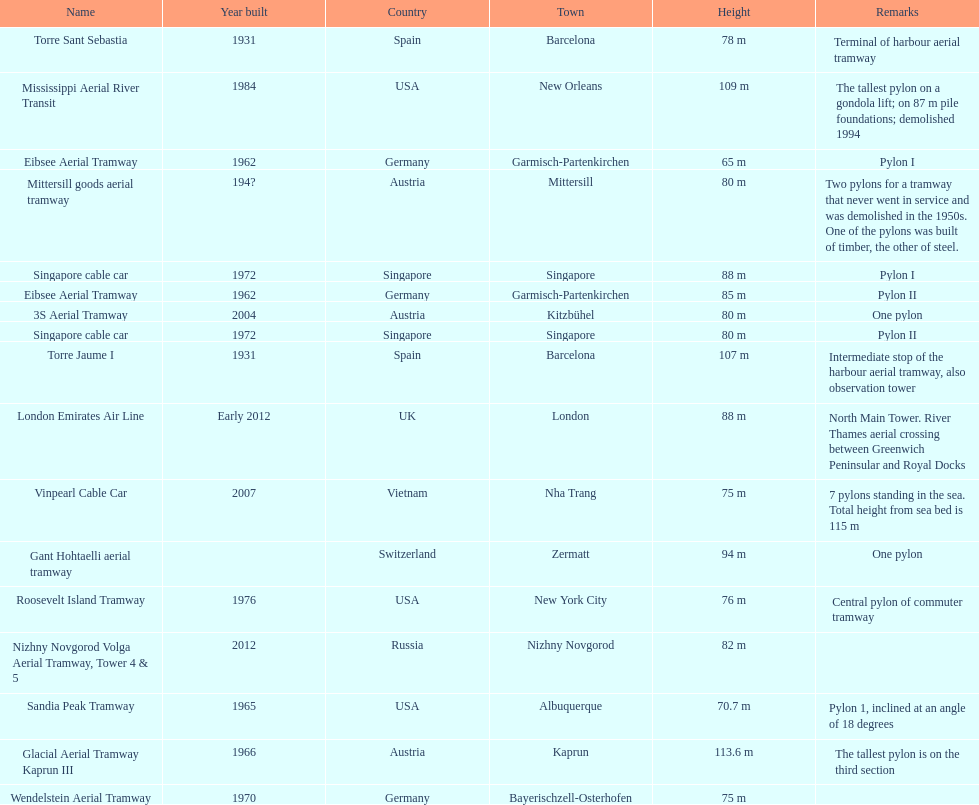What is the aggregate amount of the highest pylons in austria? 3. 